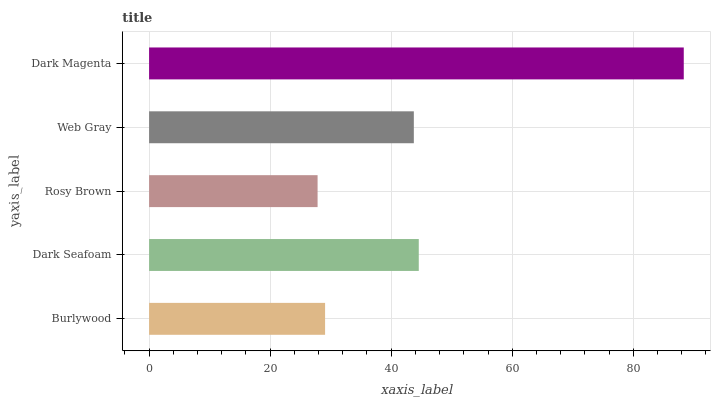Is Rosy Brown the minimum?
Answer yes or no. Yes. Is Dark Magenta the maximum?
Answer yes or no. Yes. Is Dark Seafoam the minimum?
Answer yes or no. No. Is Dark Seafoam the maximum?
Answer yes or no. No. Is Dark Seafoam greater than Burlywood?
Answer yes or no. Yes. Is Burlywood less than Dark Seafoam?
Answer yes or no. Yes. Is Burlywood greater than Dark Seafoam?
Answer yes or no. No. Is Dark Seafoam less than Burlywood?
Answer yes or no. No. Is Web Gray the high median?
Answer yes or no. Yes. Is Web Gray the low median?
Answer yes or no. Yes. Is Burlywood the high median?
Answer yes or no. No. Is Rosy Brown the low median?
Answer yes or no. No. 